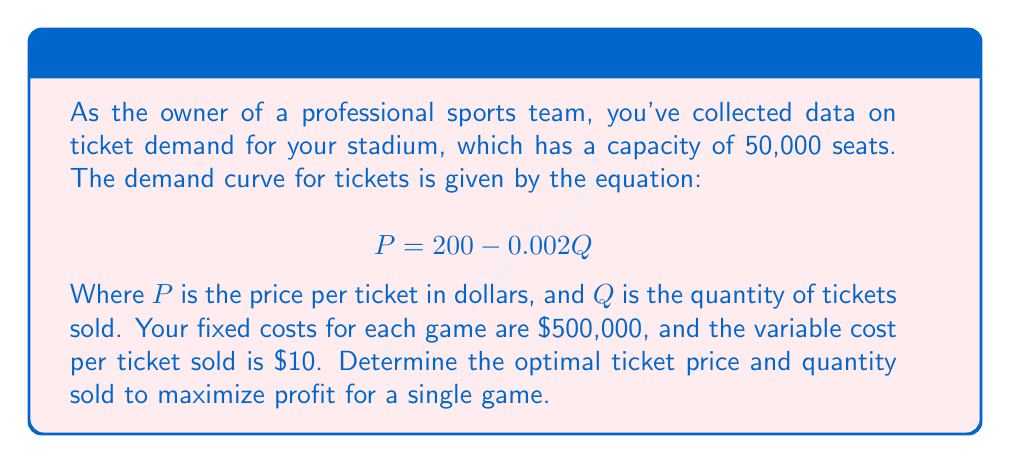Could you help me with this problem? To solve this problem, we'll follow these steps:

1) First, let's define our profit function. Profit is equal to total revenue minus total costs:

   $$\text{Profit} = \text{Total Revenue} - \text{Total Costs}$$

2) Total revenue is price times quantity:

   $$\text{TR} = P \cdot Q$$

3) Total costs are fixed costs plus variable costs times quantity:

   $$\text{TC} = 500,000 + 10Q$$

4) Substituting the demand equation for P:

   $$\text{Profit} = (200 - 0.002Q)Q - (500,000 + 10Q)$$
   $$\text{Profit} = 200Q - 0.002Q^2 - 500,000 - 10Q$$
   $$\text{Profit} = 190Q - 0.002Q^2 - 500,000$$

5) To maximize profit, we take the derivative with respect to Q and set it equal to zero:

   $$\frac{d\text{Profit}}{dQ} = 190 - 0.004Q = 0$$

6) Solving for Q:

   $$0.004Q = 190$$
   $$Q = 47,500$$

7) We need to check if this quantity is within our stadium capacity (50,000), which it is.

8) Now we can find the optimal price by plugging this quantity back into our demand equation:

   $$P = 200 - 0.002(47,500) = 105$$

9) To verify this is a maximum, we can check the second derivative:

   $$\frac{d^2\text{Profit}}{dQ^2} = -0.004$$

   This is negative, confirming we've found a maximum.

10) Finally, we can calculate the maximum profit:

    $$\text{Profit} = 190(47,500) - 0.002(47,500)^2 - 500,000 = 2,031,250$$
Answer: The optimal ticket price is $105, and the optimal quantity of tickets to sell is 47,500. This strategy will result in a maximum profit of $2,031,250 for a single game. 